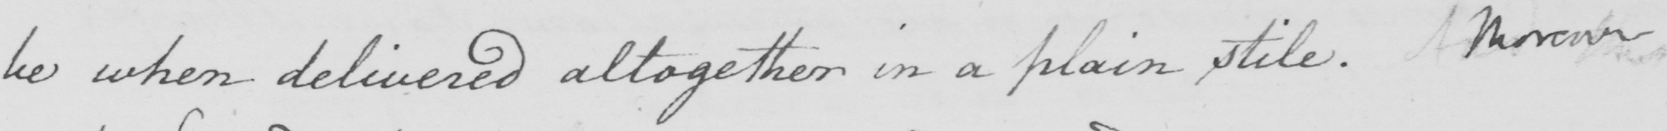Can you tell me what this handwritten text says? be when delivered altogether in a plain stile . Moreover 